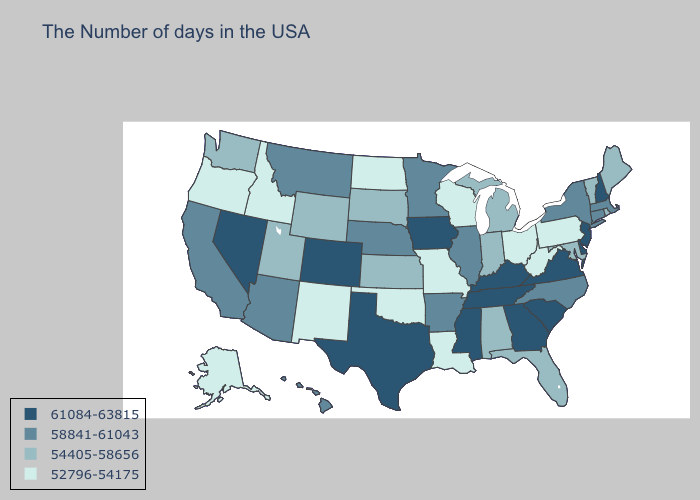Does the map have missing data?
Give a very brief answer. No. Does Pennsylvania have the lowest value in the Northeast?
Short answer required. Yes. Does Pennsylvania have the lowest value in the Northeast?
Concise answer only. Yes. Among the states that border Oregon , which have the lowest value?
Write a very short answer. Idaho. Does Texas have a higher value than Virginia?
Answer briefly. No. Does the map have missing data?
Keep it brief. No. What is the value of West Virginia?
Give a very brief answer. 52796-54175. Name the states that have a value in the range 52796-54175?
Concise answer only. Pennsylvania, West Virginia, Ohio, Wisconsin, Louisiana, Missouri, Oklahoma, North Dakota, New Mexico, Idaho, Oregon, Alaska. What is the value of Georgia?
Give a very brief answer. 61084-63815. Name the states that have a value in the range 54405-58656?
Answer briefly. Maine, Rhode Island, Vermont, Maryland, Florida, Michigan, Indiana, Alabama, Kansas, South Dakota, Wyoming, Utah, Washington. Among the states that border Kentucky , which have the lowest value?
Be succinct. West Virginia, Ohio, Missouri. What is the lowest value in the West?
Be succinct. 52796-54175. Does Kansas have the highest value in the MidWest?
Give a very brief answer. No. Does Wisconsin have the lowest value in the USA?
Concise answer only. Yes. Does Texas have the highest value in the USA?
Keep it brief. Yes. 